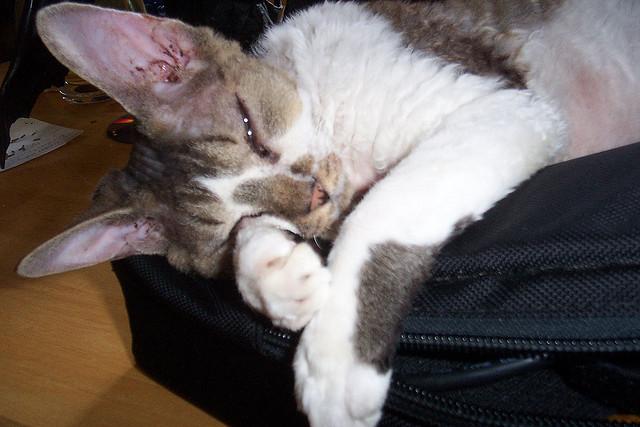What vet treatment does this cat need?
Write a very short answer. None. Does the cat look playful?
Keep it brief. No. What is the cat doing?
Answer briefly. Sleeping. 